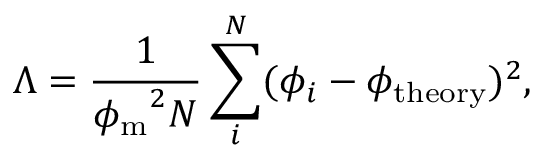Convert formula to latex. <formula><loc_0><loc_0><loc_500><loc_500>\Lambda = \frac { 1 } { { \phi _ { m } } ^ { 2 } N } \sum _ { i } ^ { N } ( \phi _ { i } - \phi _ { t h e o r y } ) ^ { 2 } ,</formula> 